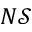Convert formula to latex. <formula><loc_0><loc_0><loc_500><loc_500>N \mathcal { S }</formula> 